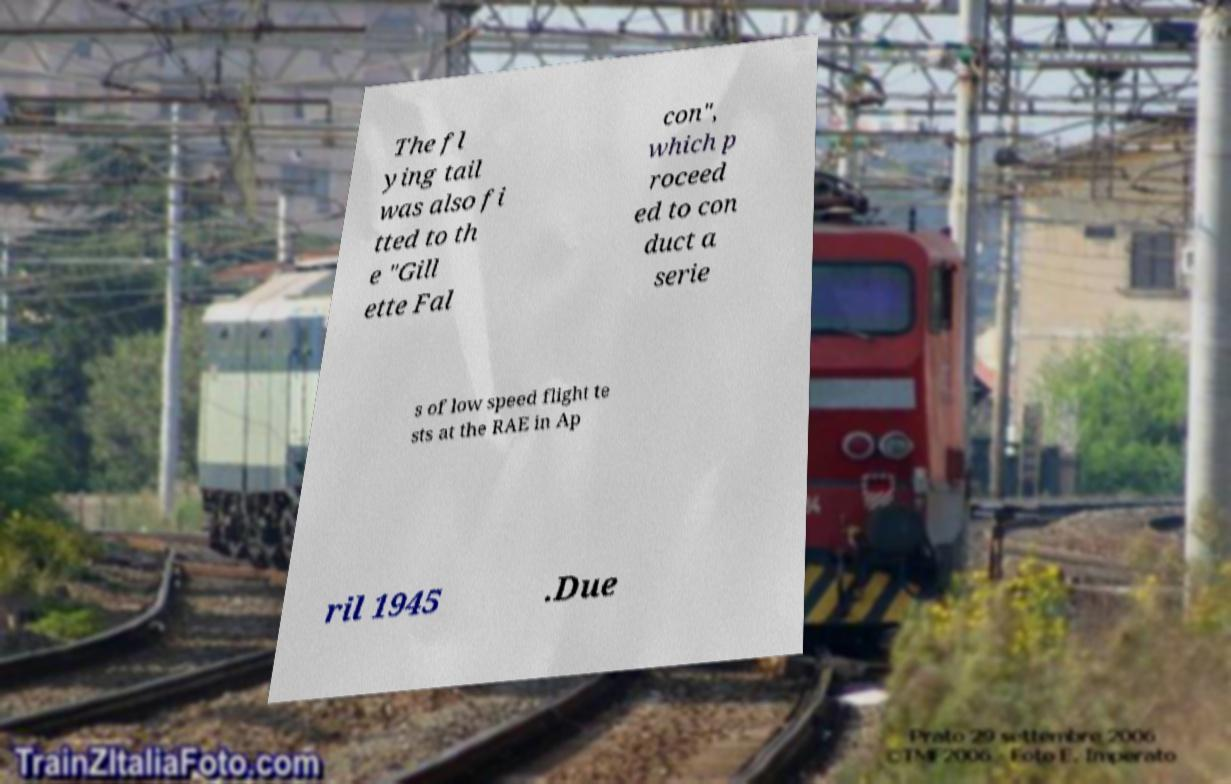Could you assist in decoding the text presented in this image and type it out clearly? The fl ying tail was also fi tted to th e "Gill ette Fal con", which p roceed ed to con duct a serie s of low speed flight te sts at the RAE in Ap ril 1945 .Due 